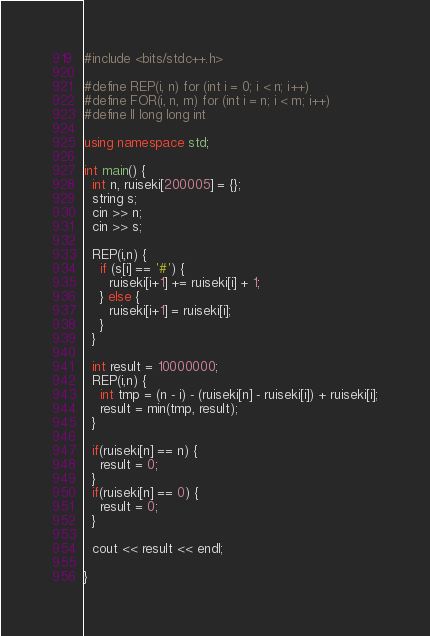<code> <loc_0><loc_0><loc_500><loc_500><_C++_>#include <bits/stdc++.h>

#define REP(i, n) for (int i = 0; i < n; i++)
#define FOR(i, n, m) for (int i = n; i < m; i++)
#define ll long long int

using namespace std;

int main() {
  int n, ruiseki[200005] = {};
  string s;
  cin >> n;
  cin >> s;

  REP(i,n) {
    if (s[i] == '#') {
      ruiseki[i+1] += ruiseki[i] + 1;
    } else {
      ruiseki[i+1] = ruiseki[i];
    }
  }

  int result = 10000000;
  REP(i,n) {
    int tmp = (n - i) - (ruiseki[n] - ruiseki[i]) + ruiseki[i];
    result = min(tmp, result);
  }

  if(ruiseki[n] == n) {
    result = 0;
  }
  if(ruiseki[n] == 0) {
    result = 0;
  }

  cout << result << endl;

}
</code> 